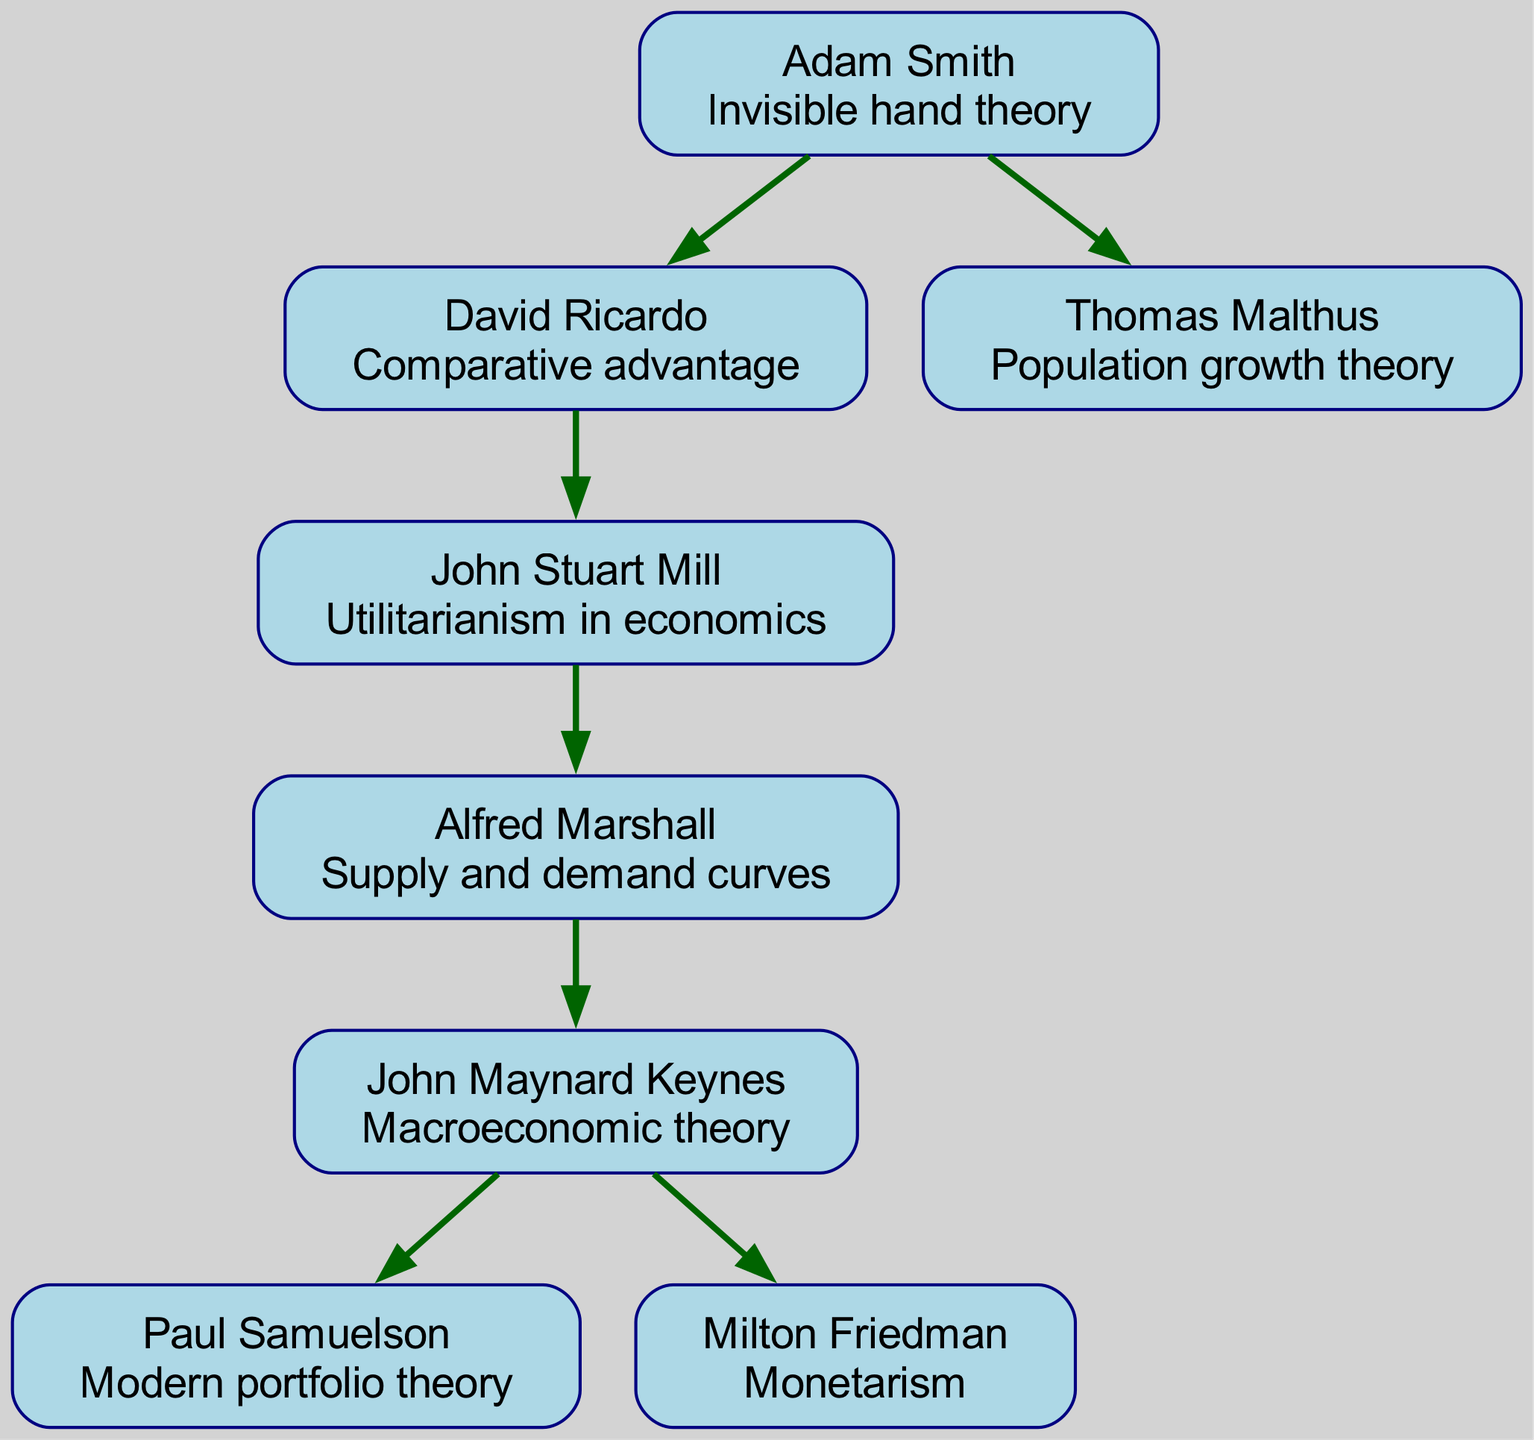What is the contribution of Adam Smith? Adam Smith is the first node in the diagram, and directly beneath his name, the contribution "Invisible hand theory" is noted. This is how the contribution is presented in the diagram.
Answer: Invisible hand theory Who are the children of John Stuart Mill? John Stuart Mill has a direct connection to one child in the diagram. When looking at Mill's node, the child listed is "Alfred Marshall", which can be found directly linked underneath his node.
Answer: Alfred Marshall How many economists contributed to macroeconomic theory? The node for John Maynard Keynes shows that he is the sole contributor to "Macroeconomic theory". This indicates that only one economist, Keynes, is responsible for this specific contribution in the diagram.
Answer: 1 Which economist is known for the supply and demand curves? Referring to the node of Alfred Marshall, his contribution is indicated as "Supply and demand curves" directly beneath his name. This clearly indicates that Marshall is known for this theory.
Answer: Alfred Marshall What is the last level of the family tree? To determine the last level, we examine the nodes with no children. The only economists without children are Thomas Malthus, Paul Samuelson, and Milton Friedman. Upon identifying these nodes in the diagram, we can ascertain that they represent the last level.
Answer: 3 Who contributed to Monetarism? Looking at the node for Milton Friedman, his contribution "Monetarism" is stated directly below his name in the diagram. This identifies him as the economist associated with this contribution.
Answer: Milton Friedman What is the relationship between Adam Smith and David Ricardo? In the diagram, Adam Smith is positioned above David Ricardo, indicating a parent-child relationship. This indicates that Adam Smith is the parent of David Ricardo in this ancestral tree structure.
Answer: Parent-child Which economist's ideas led to the development of modern portfolio theory? The contribution "Modern portfolio theory" is specifically associated with the node for Paul Samuelson, so we can conclude that Samuelson is the economist connected to this development.
Answer: Paul Samuelson 